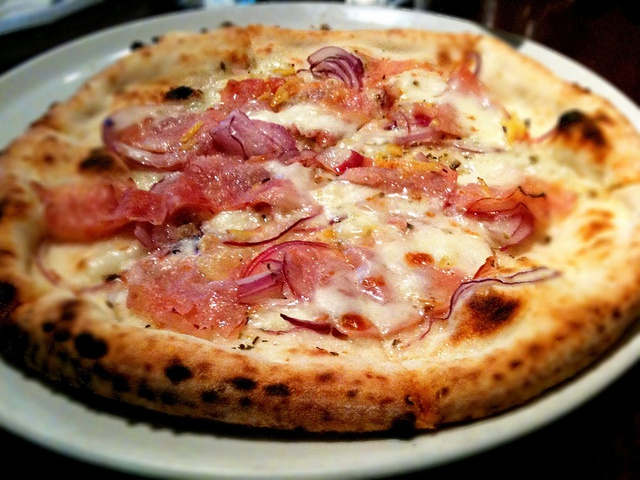Describe the objects in this image and their specific colors. I can see a pizza in gray, tan, brown, and maroon tones in this image. 